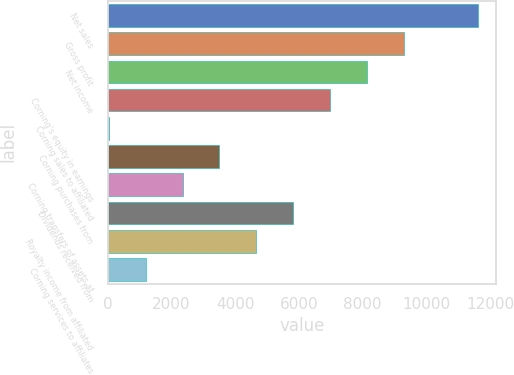<chart> <loc_0><loc_0><loc_500><loc_500><bar_chart><fcel>Net sales<fcel>Gross profit<fcel>Net income<fcel>Corning's equity in earnings<fcel>Corning sales to affiliated<fcel>Corning purchases from<fcel>Corning transfers of assets at<fcel>Dividends received from<fcel>Royalty income from affiliated<fcel>Corning services to affiliates<nl><fcel>11613<fcel>9296.4<fcel>8138.1<fcel>6979.8<fcel>30<fcel>3504.9<fcel>2346.6<fcel>5821.5<fcel>4663.2<fcel>1188.3<nl></chart> 